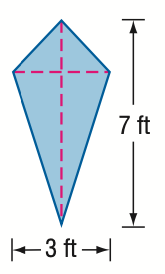Question: Find the area of the kite.
Choices:
A. 5.25
B. 10
C. 10.5
D. 21
Answer with the letter. Answer: C 